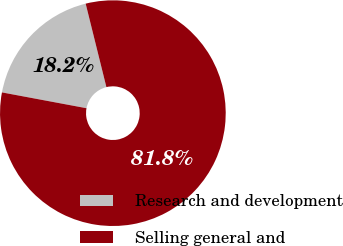Convert chart to OTSL. <chart><loc_0><loc_0><loc_500><loc_500><pie_chart><fcel>Research and development<fcel>Selling general and<nl><fcel>18.18%<fcel>81.82%<nl></chart> 